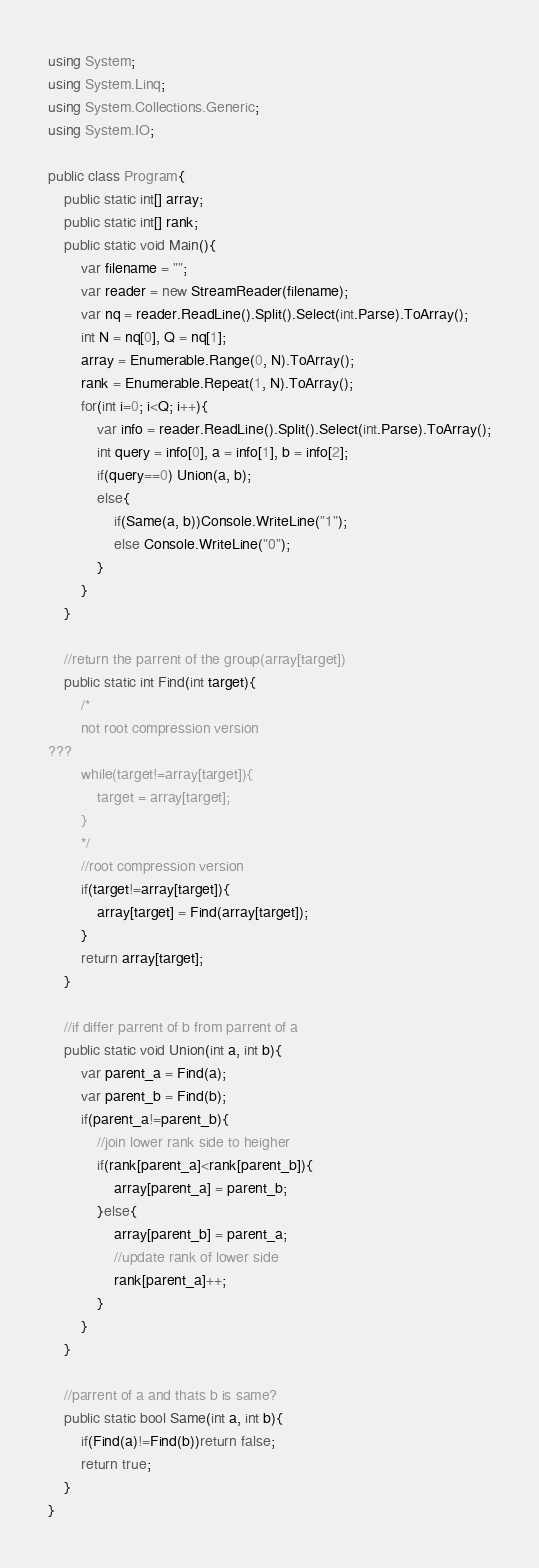<code> <loc_0><loc_0><loc_500><loc_500><_C#_>using System;
using System.Linq;
using System.Collections.Generic;
using System.IO;

public class Program{
    public static int[] array;
    public static int[] rank;
    public static void Main(){
        var filename = "";
        var reader = new StreamReader(filename);
        var nq = reader.ReadLine().Split().Select(int.Parse).ToArray();
        int N = nq[0], Q = nq[1];
        array = Enumerable.Range(0, N).ToArray();
        rank = Enumerable.Repeat(1, N).ToArray();
        for(int i=0; i<Q; i++){
            var info = reader.ReadLine().Split().Select(int.Parse).ToArray();
            int query = info[0], a = info[1], b = info[2];
            if(query==0) Union(a, b);
            else{
                if(Same(a, b))Console.WriteLine("1");
                else Console.WriteLine("0");
            }
        }
    }

    //return the parrent of the group(array[target])
    public static int Find(int target){
        /*
        not root compression version
???
        while(target!=array[target]){
            target = array[target];
        }
        */
        //root compression version
        if(target!=array[target]){
            array[target] = Find(array[target]);
        }
        return array[target];
    }

    //if differ parrent of b from parrent of a
    public static void Union(int a, int b){
        var parent_a = Find(a);
        var parent_b = Find(b);
        if(parent_a!=parent_b){
            //join lower rank side to heigher
            if(rank[parent_a]<rank[parent_b]){
                array[parent_a] = parent_b;
            }else{
                array[parent_b] = parent_a;
                //update rank of lower side
                rank[parent_a]++;
            }
        }
    }

    //parrent of a and thats b is same?
    public static bool Same(int a, int b){
        if(Find(a)!=Find(b))return false;
        return true;
    }
}</code> 